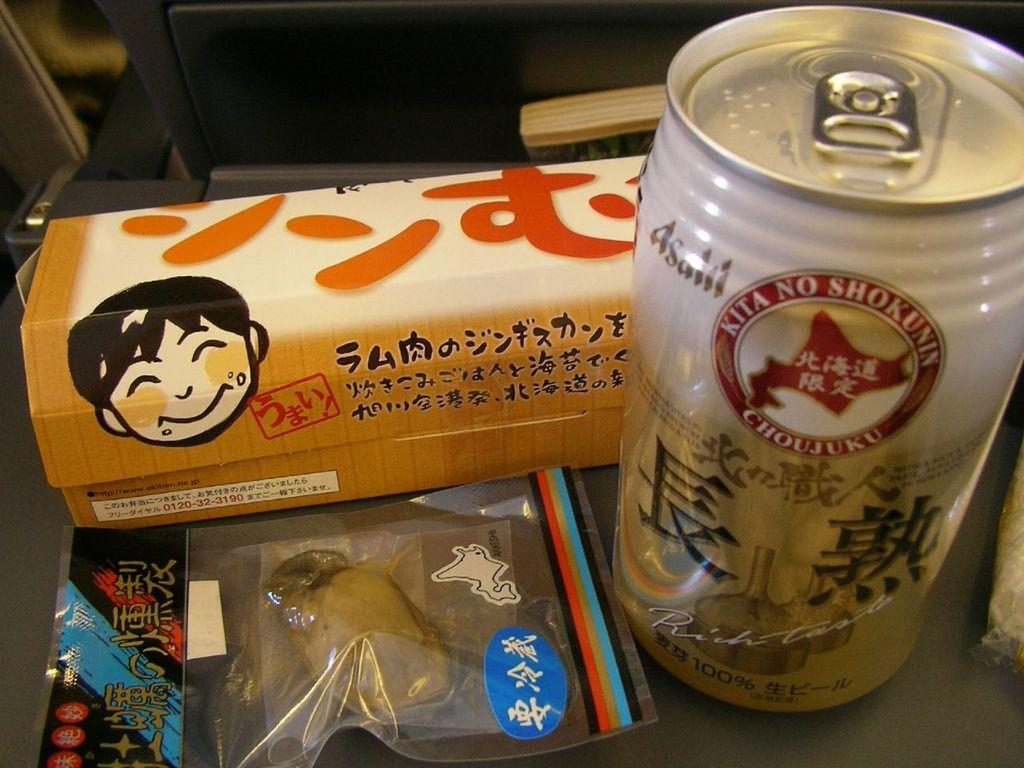<image>
Give a short and clear explanation of the subsequent image. some edible goods and a aluminum can of kita no shokunin drink 